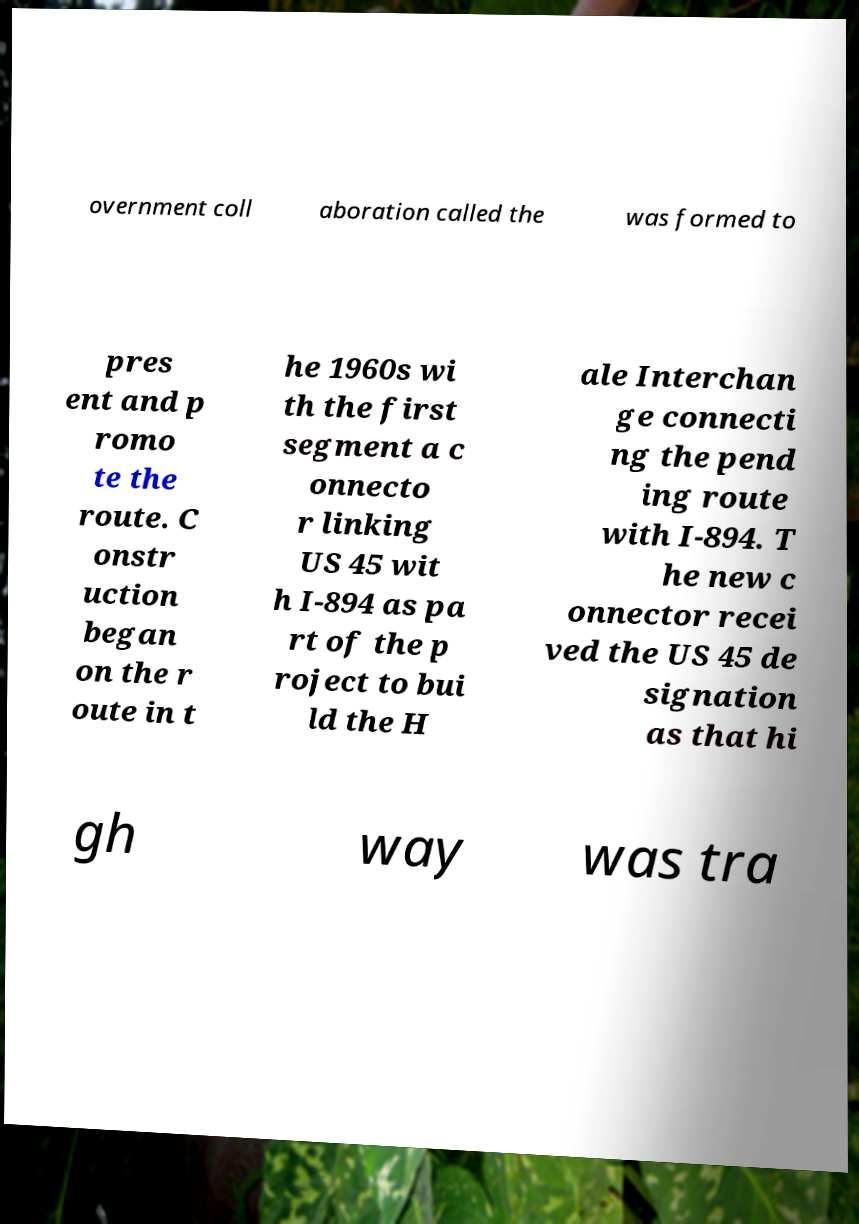Please read and relay the text visible in this image. What does it say? overnment coll aboration called the was formed to pres ent and p romo te the route. C onstr uction began on the r oute in t he 1960s wi th the first segment a c onnecto r linking US 45 wit h I-894 as pa rt of the p roject to bui ld the H ale Interchan ge connecti ng the pend ing route with I-894. T he new c onnector recei ved the US 45 de signation as that hi gh way was tra 